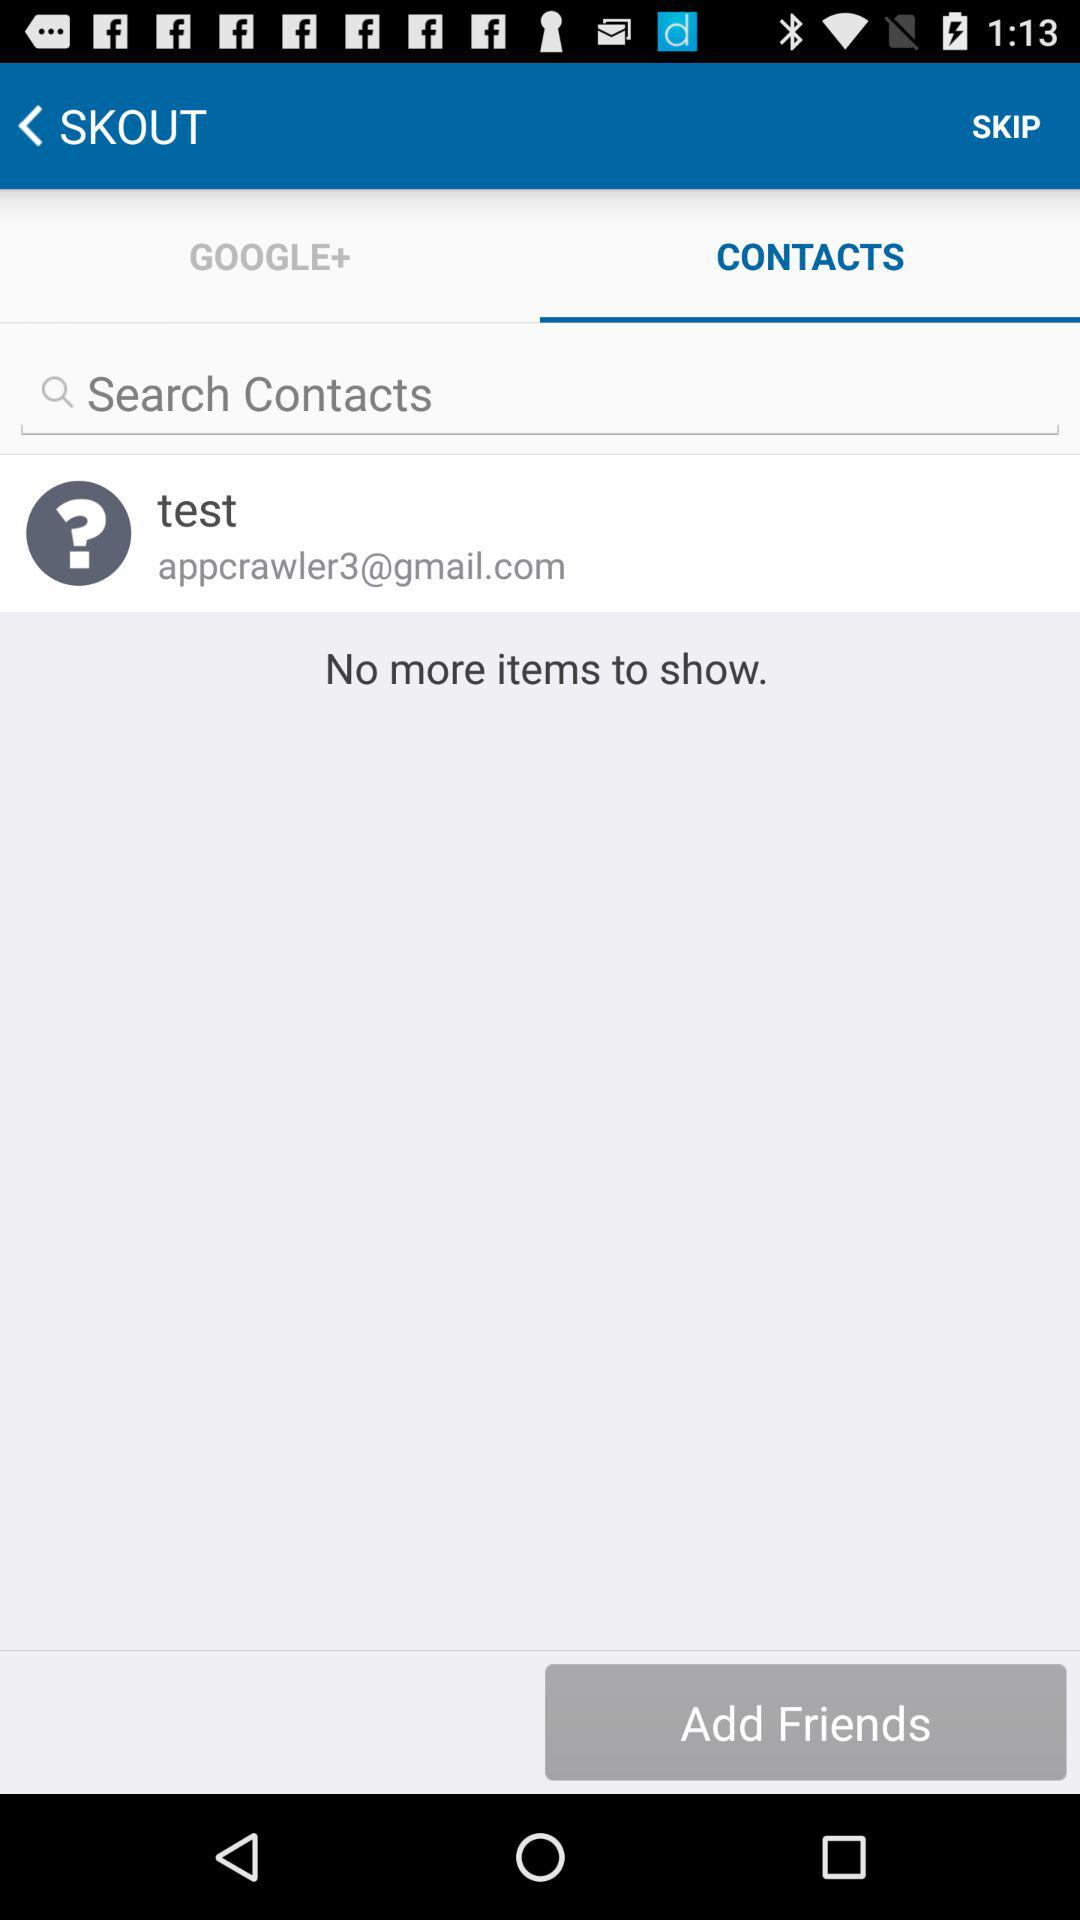What is the email address? The email address is appcrawler3@gmail.com. 